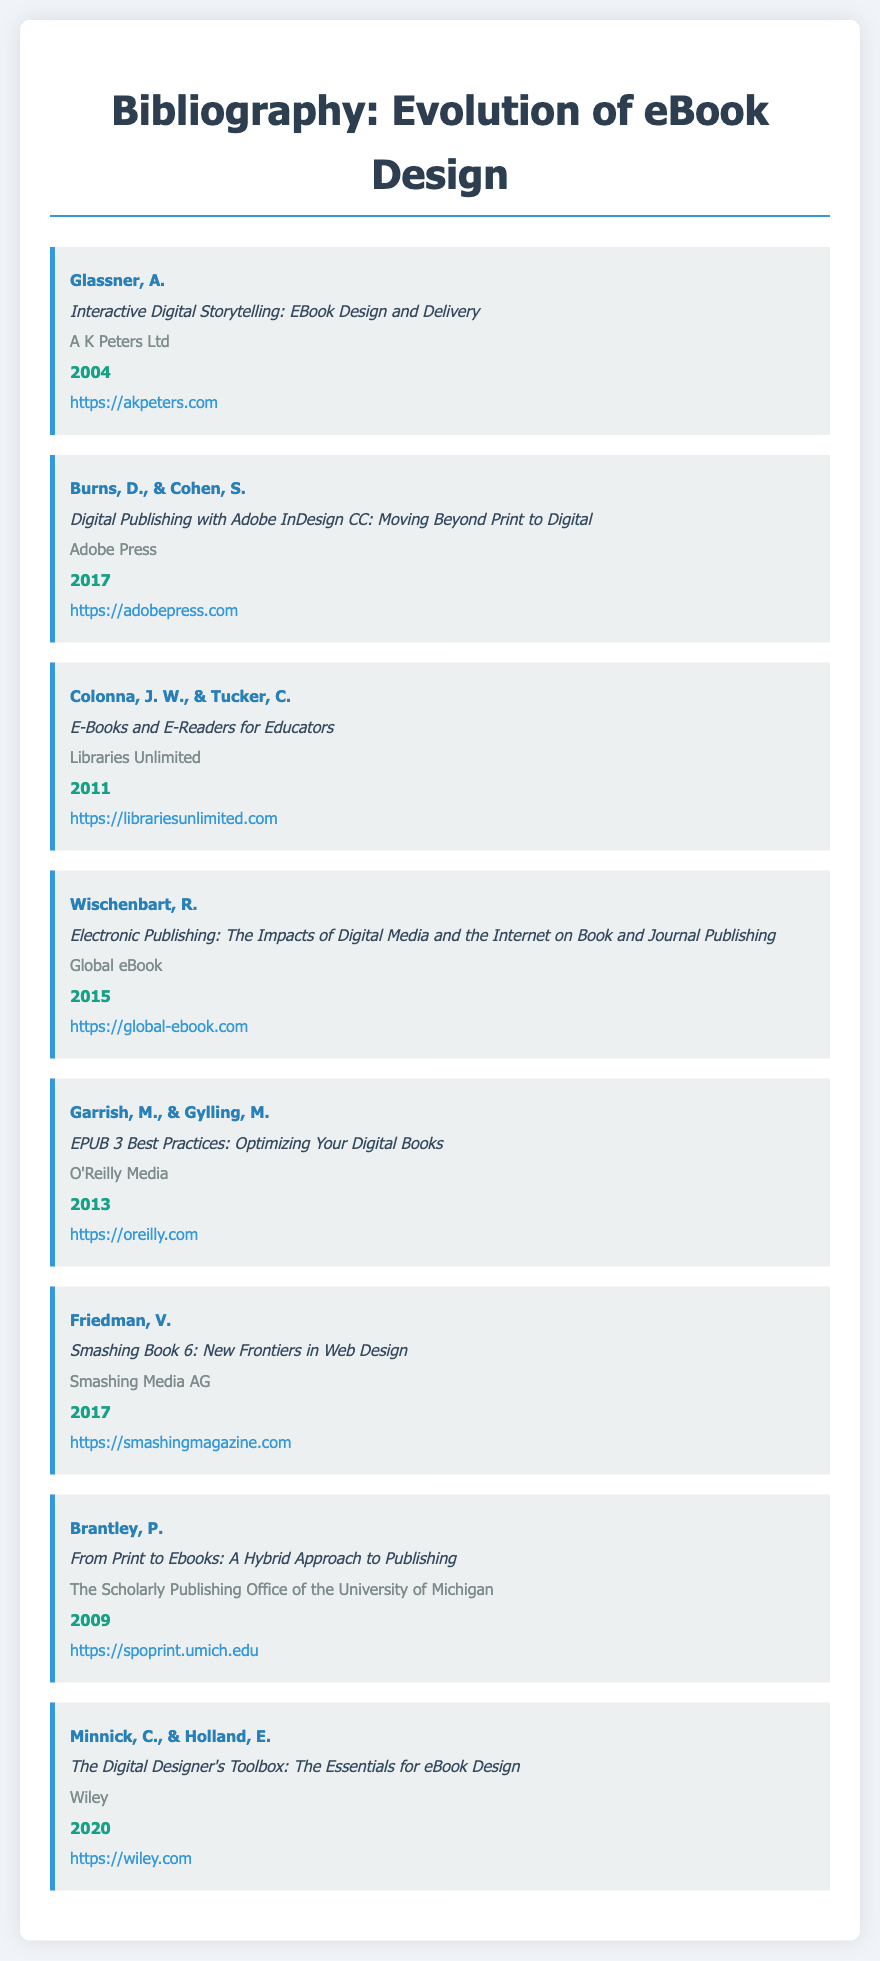what is the title of the first listed work? The title is found at the beginning of the first citation in the document.
Answer: Interactive Digital Storytelling: EBook Design and Delivery who are the authors of the book published by Adobe Press? The authors are mentioned in the specific entry for the Adobe Press publication.
Answer: Burns, D., & Cohen, S what year was "E-Books and E-Readers for Educators" published? The publication year is noted at the end of the citation for this book.
Answer: 2011 which publisher released "EPUB 3 Best Practices"? The publisher's name is included in the citation of the related work.
Answer: O'Reilly Media what is the URL for the "Smashing Book 6" publication? The URL is linked at the end of the entry for this book.
Answer: https://smashingmagazine.com how many bibliography items are listed in total? The total number of items can be counted from the listings in the bibliography section of the document.
Answer: 8 which publication discusses the impacts of digital media on publishing? This title can be identified in the bibliography that relates to digital media impacts.
Answer: Electronic Publishing: The Impacts of Digital Media and the Internet on Book and Journal Publishing what type of resource does "The Digital Designer's Toolbox" represent? The specific resource type is indicated in the title of the book.
Answer: eBook Design 